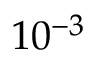<formula> <loc_0><loc_0><loc_500><loc_500>1 0 ^ { - 3 }</formula> 